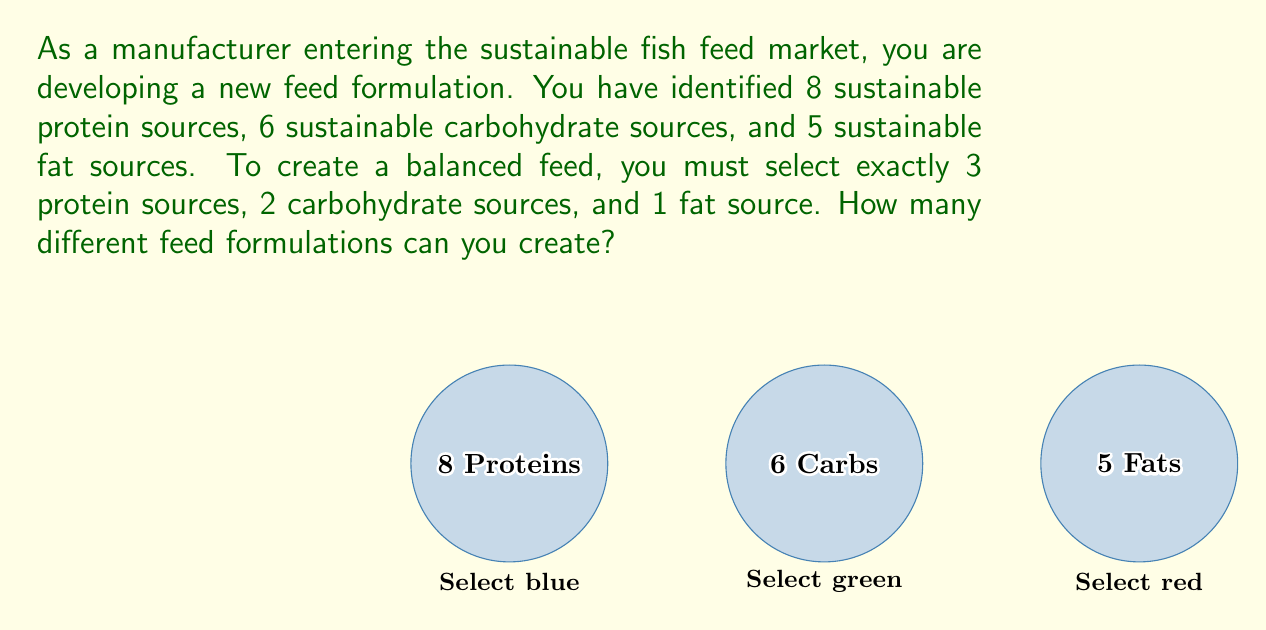Show me your answer to this math problem. To solve this problem, we need to use the combination formula for each ingredient type and then apply the multiplication principle. Let's break it down step by step:

1. For protein sources:
   We need to choose 3 out of 8 sources. This is a combination problem.
   $$\binom{8}{3} = \frac{8!}{3!(8-3)!} = \frac{8!}{3!5!} = 56$$

2. For carbohydrate sources:
   We need to choose 2 out of 6 sources.
   $$\binom{6}{2} = \frac{6!}{2!(6-2)!} = \frac{6!}{2!4!} = 15$$

3. For fat sources:
   We need to choose 1 out of 5 sources.
   $$\binom{5}{1} = \frac{5!}{1!(5-1)!} = \frac{5!}{1!4!} = 5$$

4. Now, we apply the multiplication principle. For each combination of protein sources, we can choose any combination of carbohydrate sources, and for each of those, we can choose any fat source. Therefore, we multiply the number of possibilities for each:

   $$56 \times 15 \times 5 = 4,200$$

Thus, the total number of different feed formulations is 4,200.
Answer: 4,200 formulations 